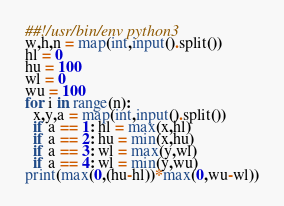<code> <loc_0><loc_0><loc_500><loc_500><_Python_>##!/usr/bin/env python3
w,h,n = map(int,input().split())
hl = 0
hu = 100
wl = 0
wu = 100
for i in range(n):
  x,y,a = map(int,input().split())
  if a == 1: hl = max(x,hl)
  if a == 2: hu = min(x,hu)
  if a == 3: wl = max(y,wl)
  if a == 4: wl = min(y,wu)
print(max(0,(hu-hl))*max(0,wu-wl))</code> 